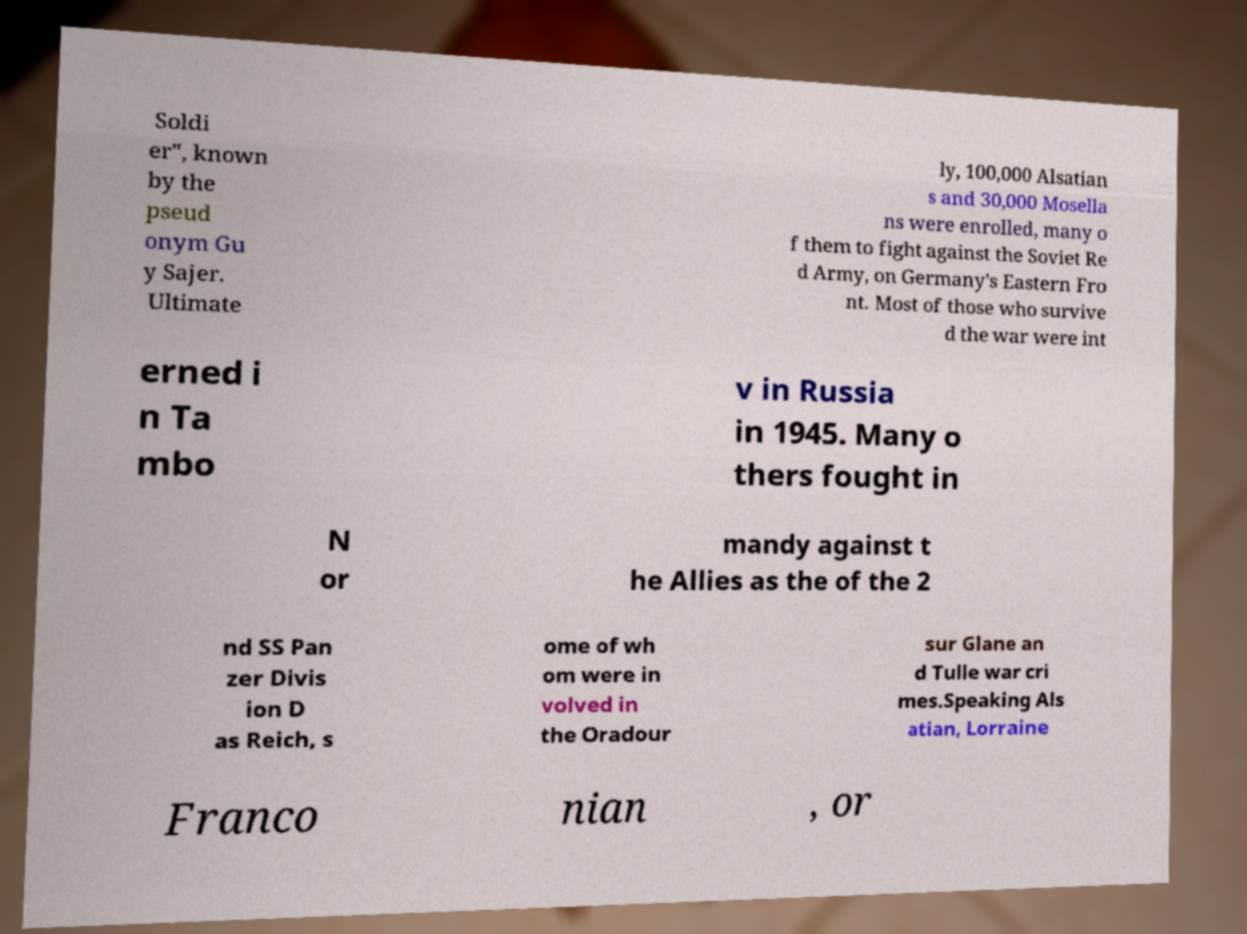Can you accurately transcribe the text from the provided image for me? Soldi er", known by the pseud onym Gu y Sajer. Ultimate ly, 100,000 Alsatian s and 30,000 Mosella ns were enrolled, many o f them to fight against the Soviet Re d Army, on Germany's Eastern Fro nt. Most of those who survive d the war were int erned i n Ta mbo v in Russia in 1945. Many o thers fought in N or mandy against t he Allies as the of the 2 nd SS Pan zer Divis ion D as Reich, s ome of wh om were in volved in the Oradour sur Glane an d Tulle war cri mes.Speaking Als atian, Lorraine Franco nian , or 